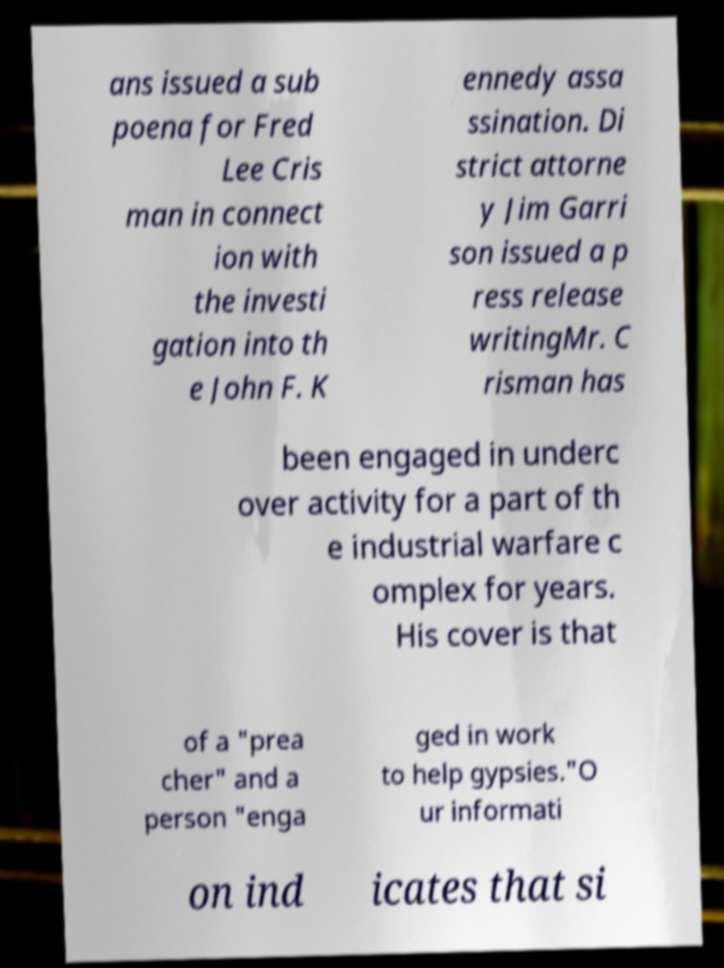Could you assist in decoding the text presented in this image and type it out clearly? ans issued a sub poena for Fred Lee Cris man in connect ion with the investi gation into th e John F. K ennedy assa ssination. Di strict attorne y Jim Garri son issued a p ress release writingMr. C risman has been engaged in underc over activity for a part of th e industrial warfare c omplex for years. His cover is that of a "prea cher" and a person "enga ged in work to help gypsies."O ur informati on ind icates that si 